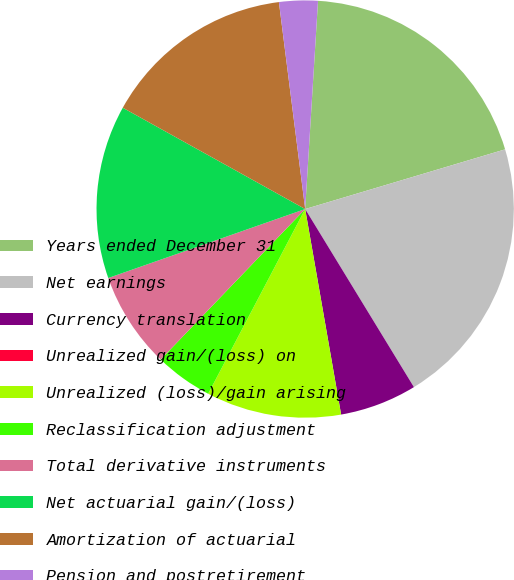Convert chart to OTSL. <chart><loc_0><loc_0><loc_500><loc_500><pie_chart><fcel>Years ended December 31<fcel>Net earnings<fcel>Currency translation<fcel>Unrealized gain/(loss) on<fcel>Unrealized (loss)/gain arising<fcel>Reclassification adjustment<fcel>Total derivative instruments<fcel>Net actuarial gain/(loss)<fcel>Amortization of actuarial<fcel>Pension and postretirement<nl><fcel>19.4%<fcel>20.89%<fcel>5.97%<fcel>0.0%<fcel>10.45%<fcel>4.48%<fcel>7.46%<fcel>13.43%<fcel>14.92%<fcel>2.99%<nl></chart> 